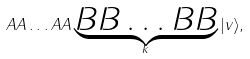Convert formula to latex. <formula><loc_0><loc_0><loc_500><loc_500>A A \dots A A \underbrace { B B \dots B B } _ { k } | v \rangle ,</formula> 